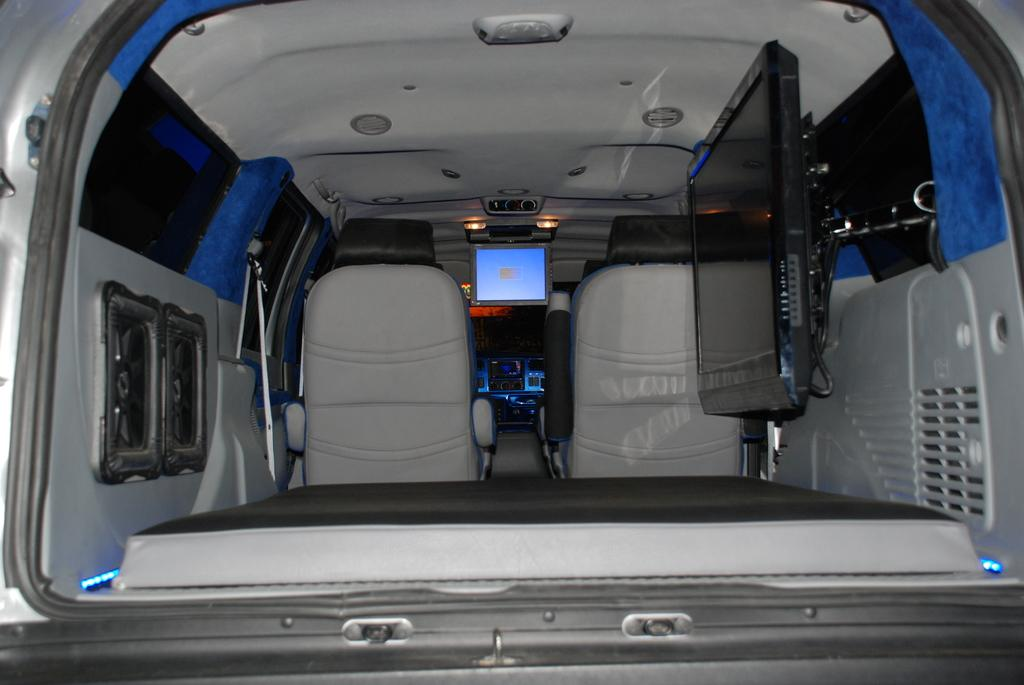What type of objects are present inside the vehicle in the image? There are seats, televisions, and lights inside the vehicle in the image. Can you describe the seating arrangement in the vehicle? The seating arrangement cannot be determined from the image, but there are seats present. What type of illumination is available inside the vehicle? There are lights present inside the vehicle. What is your dad's belief about the side of the vehicle in the image? The image does not contain any information about your dad's beliefs, nor does it show a side of the vehicle. 